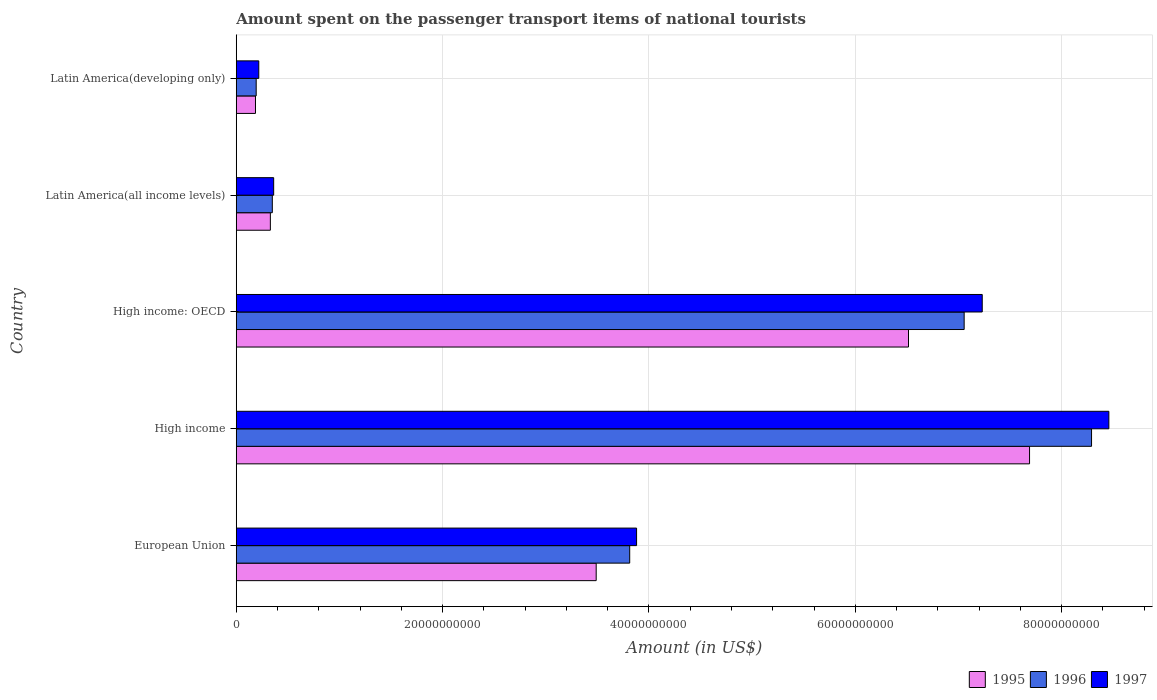How many different coloured bars are there?
Keep it short and to the point. 3. How many groups of bars are there?
Give a very brief answer. 5. Are the number of bars per tick equal to the number of legend labels?
Make the answer very short. Yes. Are the number of bars on each tick of the Y-axis equal?
Offer a terse response. Yes. How many bars are there on the 3rd tick from the bottom?
Ensure brevity in your answer.  3. What is the amount spent on the passenger transport items of national tourists in 1996 in Latin America(developing only)?
Ensure brevity in your answer.  1.93e+09. Across all countries, what is the maximum amount spent on the passenger transport items of national tourists in 1997?
Provide a short and direct response. 8.46e+1. Across all countries, what is the minimum amount spent on the passenger transport items of national tourists in 1995?
Make the answer very short. 1.86e+09. In which country was the amount spent on the passenger transport items of national tourists in 1995 minimum?
Give a very brief answer. Latin America(developing only). What is the total amount spent on the passenger transport items of national tourists in 1996 in the graph?
Offer a very short reply. 1.97e+11. What is the difference between the amount spent on the passenger transport items of national tourists in 1996 in Latin America(all income levels) and that in Latin America(developing only)?
Make the answer very short. 1.56e+09. What is the difference between the amount spent on the passenger transport items of national tourists in 1995 in European Union and the amount spent on the passenger transport items of national tourists in 1996 in High income?
Provide a short and direct response. -4.80e+1. What is the average amount spent on the passenger transport items of national tourists in 1996 per country?
Provide a succinct answer. 3.94e+1. What is the difference between the amount spent on the passenger transport items of national tourists in 1996 and amount spent on the passenger transport items of national tourists in 1995 in High income?
Ensure brevity in your answer.  6.01e+09. In how many countries, is the amount spent on the passenger transport items of national tourists in 1996 greater than 72000000000 US$?
Your answer should be compact. 1. What is the ratio of the amount spent on the passenger transport items of national tourists in 1996 in High income to that in Latin America(all income levels)?
Your response must be concise. 23.72. Is the difference between the amount spent on the passenger transport items of national tourists in 1996 in High income and Latin America(developing only) greater than the difference between the amount spent on the passenger transport items of national tourists in 1995 in High income and Latin America(developing only)?
Keep it short and to the point. Yes. What is the difference between the highest and the second highest amount spent on the passenger transport items of national tourists in 1996?
Give a very brief answer. 1.23e+1. What is the difference between the highest and the lowest amount spent on the passenger transport items of national tourists in 1997?
Keep it short and to the point. 8.24e+1. What does the 1st bar from the bottom in High income: OECD represents?
Keep it short and to the point. 1995. How many bars are there?
Offer a terse response. 15. How many countries are there in the graph?
Keep it short and to the point. 5. What is the difference between two consecutive major ticks on the X-axis?
Offer a terse response. 2.00e+1. Are the values on the major ticks of X-axis written in scientific E-notation?
Provide a succinct answer. No. Does the graph contain any zero values?
Provide a succinct answer. No. Does the graph contain grids?
Offer a very short reply. Yes. Where does the legend appear in the graph?
Make the answer very short. Bottom right. How are the legend labels stacked?
Your answer should be very brief. Horizontal. What is the title of the graph?
Offer a very short reply. Amount spent on the passenger transport items of national tourists. Does "1984" appear as one of the legend labels in the graph?
Provide a short and direct response. No. What is the label or title of the X-axis?
Your answer should be very brief. Amount (in US$). What is the Amount (in US$) of 1995 in European Union?
Make the answer very short. 3.49e+1. What is the Amount (in US$) in 1996 in European Union?
Provide a succinct answer. 3.81e+1. What is the Amount (in US$) in 1997 in European Union?
Provide a succinct answer. 3.88e+1. What is the Amount (in US$) of 1995 in High income?
Ensure brevity in your answer.  7.69e+1. What is the Amount (in US$) of 1996 in High income?
Make the answer very short. 8.29e+1. What is the Amount (in US$) in 1997 in High income?
Offer a terse response. 8.46e+1. What is the Amount (in US$) in 1995 in High income: OECD?
Your response must be concise. 6.52e+1. What is the Amount (in US$) in 1996 in High income: OECD?
Make the answer very short. 7.06e+1. What is the Amount (in US$) in 1997 in High income: OECD?
Keep it short and to the point. 7.23e+1. What is the Amount (in US$) of 1995 in Latin America(all income levels)?
Your response must be concise. 3.31e+09. What is the Amount (in US$) in 1996 in Latin America(all income levels)?
Offer a very short reply. 3.50e+09. What is the Amount (in US$) in 1997 in Latin America(all income levels)?
Provide a short and direct response. 3.63e+09. What is the Amount (in US$) in 1995 in Latin America(developing only)?
Ensure brevity in your answer.  1.86e+09. What is the Amount (in US$) of 1996 in Latin America(developing only)?
Provide a succinct answer. 1.93e+09. What is the Amount (in US$) in 1997 in Latin America(developing only)?
Keep it short and to the point. 2.18e+09. Across all countries, what is the maximum Amount (in US$) of 1995?
Make the answer very short. 7.69e+1. Across all countries, what is the maximum Amount (in US$) of 1996?
Offer a very short reply. 8.29e+1. Across all countries, what is the maximum Amount (in US$) of 1997?
Offer a terse response. 8.46e+1. Across all countries, what is the minimum Amount (in US$) of 1995?
Give a very brief answer. 1.86e+09. Across all countries, what is the minimum Amount (in US$) of 1996?
Offer a very short reply. 1.93e+09. Across all countries, what is the minimum Amount (in US$) in 1997?
Provide a succinct answer. 2.18e+09. What is the total Amount (in US$) in 1995 in the graph?
Give a very brief answer. 1.82e+11. What is the total Amount (in US$) in 1996 in the graph?
Provide a succinct answer. 1.97e+11. What is the total Amount (in US$) in 1997 in the graph?
Your answer should be compact. 2.01e+11. What is the difference between the Amount (in US$) of 1995 in European Union and that in High income?
Your answer should be very brief. -4.20e+1. What is the difference between the Amount (in US$) in 1996 in European Union and that in High income?
Provide a succinct answer. -4.48e+1. What is the difference between the Amount (in US$) of 1997 in European Union and that in High income?
Provide a short and direct response. -4.58e+1. What is the difference between the Amount (in US$) of 1995 in European Union and that in High income: OECD?
Give a very brief answer. -3.03e+1. What is the difference between the Amount (in US$) in 1996 in European Union and that in High income: OECD?
Provide a short and direct response. -3.24e+1. What is the difference between the Amount (in US$) of 1997 in European Union and that in High income: OECD?
Your answer should be compact. -3.35e+1. What is the difference between the Amount (in US$) in 1995 in European Union and that in Latin America(all income levels)?
Offer a terse response. 3.16e+1. What is the difference between the Amount (in US$) in 1996 in European Union and that in Latin America(all income levels)?
Offer a very short reply. 3.46e+1. What is the difference between the Amount (in US$) in 1997 in European Union and that in Latin America(all income levels)?
Keep it short and to the point. 3.52e+1. What is the difference between the Amount (in US$) of 1995 in European Union and that in Latin America(developing only)?
Provide a succinct answer. 3.30e+1. What is the difference between the Amount (in US$) in 1996 in European Union and that in Latin America(developing only)?
Provide a short and direct response. 3.62e+1. What is the difference between the Amount (in US$) of 1997 in European Union and that in Latin America(developing only)?
Your answer should be compact. 3.66e+1. What is the difference between the Amount (in US$) of 1995 in High income and that in High income: OECD?
Give a very brief answer. 1.17e+1. What is the difference between the Amount (in US$) in 1996 in High income and that in High income: OECD?
Keep it short and to the point. 1.23e+1. What is the difference between the Amount (in US$) of 1997 in High income and that in High income: OECD?
Make the answer very short. 1.23e+1. What is the difference between the Amount (in US$) of 1995 in High income and that in Latin America(all income levels)?
Your answer should be compact. 7.36e+1. What is the difference between the Amount (in US$) in 1996 in High income and that in Latin America(all income levels)?
Make the answer very short. 7.94e+1. What is the difference between the Amount (in US$) of 1997 in High income and that in Latin America(all income levels)?
Your answer should be very brief. 8.10e+1. What is the difference between the Amount (in US$) in 1995 in High income and that in Latin America(developing only)?
Give a very brief answer. 7.50e+1. What is the difference between the Amount (in US$) of 1996 in High income and that in Latin America(developing only)?
Offer a very short reply. 8.10e+1. What is the difference between the Amount (in US$) in 1997 in High income and that in Latin America(developing only)?
Provide a short and direct response. 8.24e+1. What is the difference between the Amount (in US$) in 1995 in High income: OECD and that in Latin America(all income levels)?
Your answer should be very brief. 6.19e+1. What is the difference between the Amount (in US$) in 1996 in High income: OECD and that in Latin America(all income levels)?
Your answer should be compact. 6.71e+1. What is the difference between the Amount (in US$) of 1997 in High income: OECD and that in Latin America(all income levels)?
Provide a succinct answer. 6.87e+1. What is the difference between the Amount (in US$) of 1995 in High income: OECD and that in Latin America(developing only)?
Keep it short and to the point. 6.33e+1. What is the difference between the Amount (in US$) in 1996 in High income: OECD and that in Latin America(developing only)?
Provide a short and direct response. 6.86e+1. What is the difference between the Amount (in US$) of 1997 in High income: OECD and that in Latin America(developing only)?
Offer a terse response. 7.01e+1. What is the difference between the Amount (in US$) in 1995 in Latin America(all income levels) and that in Latin America(developing only)?
Your response must be concise. 1.44e+09. What is the difference between the Amount (in US$) in 1996 in Latin America(all income levels) and that in Latin America(developing only)?
Offer a very short reply. 1.56e+09. What is the difference between the Amount (in US$) in 1997 in Latin America(all income levels) and that in Latin America(developing only)?
Provide a short and direct response. 1.44e+09. What is the difference between the Amount (in US$) of 1995 in European Union and the Amount (in US$) of 1996 in High income?
Ensure brevity in your answer.  -4.80e+1. What is the difference between the Amount (in US$) of 1995 in European Union and the Amount (in US$) of 1997 in High income?
Your response must be concise. -4.97e+1. What is the difference between the Amount (in US$) in 1996 in European Union and the Amount (in US$) in 1997 in High income?
Keep it short and to the point. -4.64e+1. What is the difference between the Amount (in US$) in 1995 in European Union and the Amount (in US$) in 1996 in High income: OECD?
Your answer should be compact. -3.57e+1. What is the difference between the Amount (in US$) of 1995 in European Union and the Amount (in US$) of 1997 in High income: OECD?
Give a very brief answer. -3.74e+1. What is the difference between the Amount (in US$) of 1996 in European Union and the Amount (in US$) of 1997 in High income: OECD?
Give a very brief answer. -3.42e+1. What is the difference between the Amount (in US$) of 1995 in European Union and the Amount (in US$) of 1996 in Latin America(all income levels)?
Give a very brief answer. 3.14e+1. What is the difference between the Amount (in US$) in 1995 in European Union and the Amount (in US$) in 1997 in Latin America(all income levels)?
Your answer should be compact. 3.13e+1. What is the difference between the Amount (in US$) of 1996 in European Union and the Amount (in US$) of 1997 in Latin America(all income levels)?
Keep it short and to the point. 3.45e+1. What is the difference between the Amount (in US$) of 1995 in European Union and the Amount (in US$) of 1996 in Latin America(developing only)?
Keep it short and to the point. 3.30e+1. What is the difference between the Amount (in US$) in 1995 in European Union and the Amount (in US$) in 1997 in Latin America(developing only)?
Keep it short and to the point. 3.27e+1. What is the difference between the Amount (in US$) of 1996 in European Union and the Amount (in US$) of 1997 in Latin America(developing only)?
Your answer should be very brief. 3.60e+1. What is the difference between the Amount (in US$) of 1995 in High income and the Amount (in US$) of 1996 in High income: OECD?
Offer a very short reply. 6.34e+09. What is the difference between the Amount (in US$) in 1995 in High income and the Amount (in US$) in 1997 in High income: OECD?
Keep it short and to the point. 4.59e+09. What is the difference between the Amount (in US$) in 1996 in High income and the Amount (in US$) in 1997 in High income: OECD?
Offer a terse response. 1.06e+1. What is the difference between the Amount (in US$) in 1995 in High income and the Amount (in US$) in 1996 in Latin America(all income levels)?
Ensure brevity in your answer.  7.34e+1. What is the difference between the Amount (in US$) in 1995 in High income and the Amount (in US$) in 1997 in Latin America(all income levels)?
Provide a short and direct response. 7.33e+1. What is the difference between the Amount (in US$) of 1996 in High income and the Amount (in US$) of 1997 in Latin America(all income levels)?
Your answer should be compact. 7.93e+1. What is the difference between the Amount (in US$) in 1995 in High income and the Amount (in US$) in 1996 in Latin America(developing only)?
Make the answer very short. 7.50e+1. What is the difference between the Amount (in US$) of 1995 in High income and the Amount (in US$) of 1997 in Latin America(developing only)?
Your answer should be compact. 7.47e+1. What is the difference between the Amount (in US$) of 1996 in High income and the Amount (in US$) of 1997 in Latin America(developing only)?
Keep it short and to the point. 8.07e+1. What is the difference between the Amount (in US$) in 1995 in High income: OECD and the Amount (in US$) in 1996 in Latin America(all income levels)?
Your answer should be very brief. 6.17e+1. What is the difference between the Amount (in US$) of 1995 in High income: OECD and the Amount (in US$) of 1997 in Latin America(all income levels)?
Provide a short and direct response. 6.15e+1. What is the difference between the Amount (in US$) of 1996 in High income: OECD and the Amount (in US$) of 1997 in Latin America(all income levels)?
Give a very brief answer. 6.69e+1. What is the difference between the Amount (in US$) in 1995 in High income: OECD and the Amount (in US$) in 1996 in Latin America(developing only)?
Your response must be concise. 6.32e+1. What is the difference between the Amount (in US$) in 1995 in High income: OECD and the Amount (in US$) in 1997 in Latin America(developing only)?
Your answer should be very brief. 6.30e+1. What is the difference between the Amount (in US$) of 1996 in High income: OECD and the Amount (in US$) of 1997 in Latin America(developing only)?
Offer a terse response. 6.84e+1. What is the difference between the Amount (in US$) in 1995 in Latin America(all income levels) and the Amount (in US$) in 1996 in Latin America(developing only)?
Ensure brevity in your answer.  1.37e+09. What is the difference between the Amount (in US$) of 1995 in Latin America(all income levels) and the Amount (in US$) of 1997 in Latin America(developing only)?
Make the answer very short. 1.12e+09. What is the difference between the Amount (in US$) in 1996 in Latin America(all income levels) and the Amount (in US$) in 1997 in Latin America(developing only)?
Your answer should be very brief. 1.31e+09. What is the average Amount (in US$) in 1995 per country?
Offer a terse response. 3.64e+1. What is the average Amount (in US$) of 1996 per country?
Ensure brevity in your answer.  3.94e+1. What is the average Amount (in US$) in 1997 per country?
Ensure brevity in your answer.  4.03e+1. What is the difference between the Amount (in US$) of 1995 and Amount (in US$) of 1996 in European Union?
Your answer should be very brief. -3.25e+09. What is the difference between the Amount (in US$) in 1995 and Amount (in US$) in 1997 in European Union?
Offer a very short reply. -3.92e+09. What is the difference between the Amount (in US$) in 1996 and Amount (in US$) in 1997 in European Union?
Provide a short and direct response. -6.67e+08. What is the difference between the Amount (in US$) in 1995 and Amount (in US$) in 1996 in High income?
Your response must be concise. -6.01e+09. What is the difference between the Amount (in US$) of 1995 and Amount (in US$) of 1997 in High income?
Your answer should be very brief. -7.69e+09. What is the difference between the Amount (in US$) of 1996 and Amount (in US$) of 1997 in High income?
Ensure brevity in your answer.  -1.68e+09. What is the difference between the Amount (in US$) of 1995 and Amount (in US$) of 1996 in High income: OECD?
Keep it short and to the point. -5.40e+09. What is the difference between the Amount (in US$) in 1995 and Amount (in US$) in 1997 in High income: OECD?
Your answer should be very brief. -7.15e+09. What is the difference between the Amount (in US$) of 1996 and Amount (in US$) of 1997 in High income: OECD?
Your answer should be compact. -1.75e+09. What is the difference between the Amount (in US$) of 1995 and Amount (in US$) of 1996 in Latin America(all income levels)?
Offer a terse response. -1.89e+08. What is the difference between the Amount (in US$) in 1995 and Amount (in US$) in 1997 in Latin America(all income levels)?
Ensure brevity in your answer.  -3.20e+08. What is the difference between the Amount (in US$) of 1996 and Amount (in US$) of 1997 in Latin America(all income levels)?
Keep it short and to the point. -1.31e+08. What is the difference between the Amount (in US$) in 1995 and Amount (in US$) in 1996 in Latin America(developing only)?
Your response must be concise. -6.84e+07. What is the difference between the Amount (in US$) of 1995 and Amount (in US$) of 1997 in Latin America(developing only)?
Provide a succinct answer. -3.19e+08. What is the difference between the Amount (in US$) in 1996 and Amount (in US$) in 1997 in Latin America(developing only)?
Offer a very short reply. -2.50e+08. What is the ratio of the Amount (in US$) of 1995 in European Union to that in High income?
Your answer should be very brief. 0.45. What is the ratio of the Amount (in US$) in 1996 in European Union to that in High income?
Offer a terse response. 0.46. What is the ratio of the Amount (in US$) in 1997 in European Union to that in High income?
Offer a terse response. 0.46. What is the ratio of the Amount (in US$) of 1995 in European Union to that in High income: OECD?
Offer a very short reply. 0.54. What is the ratio of the Amount (in US$) in 1996 in European Union to that in High income: OECD?
Your response must be concise. 0.54. What is the ratio of the Amount (in US$) of 1997 in European Union to that in High income: OECD?
Offer a very short reply. 0.54. What is the ratio of the Amount (in US$) in 1995 in European Union to that in Latin America(all income levels)?
Offer a terse response. 10.55. What is the ratio of the Amount (in US$) of 1996 in European Union to that in Latin America(all income levels)?
Your answer should be very brief. 10.91. What is the ratio of the Amount (in US$) in 1997 in European Union to that in Latin America(all income levels)?
Offer a very short reply. 10.7. What is the ratio of the Amount (in US$) of 1995 in European Union to that in Latin America(developing only)?
Give a very brief answer. 18.71. What is the ratio of the Amount (in US$) in 1996 in European Union to that in Latin America(developing only)?
Give a very brief answer. 19.73. What is the ratio of the Amount (in US$) in 1997 in European Union to that in Latin America(developing only)?
Ensure brevity in your answer.  17.78. What is the ratio of the Amount (in US$) of 1995 in High income to that in High income: OECD?
Ensure brevity in your answer.  1.18. What is the ratio of the Amount (in US$) of 1996 in High income to that in High income: OECD?
Offer a very short reply. 1.18. What is the ratio of the Amount (in US$) of 1997 in High income to that in High income: OECD?
Your answer should be compact. 1.17. What is the ratio of the Amount (in US$) of 1995 in High income to that in Latin America(all income levels)?
Provide a short and direct response. 23.26. What is the ratio of the Amount (in US$) in 1996 in High income to that in Latin America(all income levels)?
Your answer should be compact. 23.72. What is the ratio of the Amount (in US$) of 1997 in High income to that in Latin America(all income levels)?
Your answer should be very brief. 23.32. What is the ratio of the Amount (in US$) of 1995 in High income to that in Latin America(developing only)?
Keep it short and to the point. 41.24. What is the ratio of the Amount (in US$) in 1996 in High income to that in Latin America(developing only)?
Provide a short and direct response. 42.9. What is the ratio of the Amount (in US$) of 1997 in High income to that in Latin America(developing only)?
Your answer should be very brief. 38.75. What is the ratio of the Amount (in US$) of 1995 in High income: OECD to that in Latin America(all income levels)?
Give a very brief answer. 19.71. What is the ratio of the Amount (in US$) in 1996 in High income: OECD to that in Latin America(all income levels)?
Your response must be concise. 20.19. What is the ratio of the Amount (in US$) in 1997 in High income: OECD to that in Latin America(all income levels)?
Keep it short and to the point. 19.94. What is the ratio of the Amount (in US$) of 1995 in High income: OECD to that in Latin America(developing only)?
Give a very brief answer. 34.95. What is the ratio of the Amount (in US$) of 1996 in High income: OECD to that in Latin America(developing only)?
Offer a very short reply. 36.51. What is the ratio of the Amount (in US$) of 1997 in High income: OECD to that in Latin America(developing only)?
Your answer should be compact. 33.12. What is the ratio of the Amount (in US$) in 1995 in Latin America(all income levels) to that in Latin America(developing only)?
Provide a succinct answer. 1.77. What is the ratio of the Amount (in US$) in 1996 in Latin America(all income levels) to that in Latin America(developing only)?
Keep it short and to the point. 1.81. What is the ratio of the Amount (in US$) in 1997 in Latin America(all income levels) to that in Latin America(developing only)?
Keep it short and to the point. 1.66. What is the difference between the highest and the second highest Amount (in US$) of 1995?
Your response must be concise. 1.17e+1. What is the difference between the highest and the second highest Amount (in US$) of 1996?
Your response must be concise. 1.23e+1. What is the difference between the highest and the second highest Amount (in US$) of 1997?
Ensure brevity in your answer.  1.23e+1. What is the difference between the highest and the lowest Amount (in US$) of 1995?
Offer a very short reply. 7.50e+1. What is the difference between the highest and the lowest Amount (in US$) of 1996?
Your answer should be compact. 8.10e+1. What is the difference between the highest and the lowest Amount (in US$) in 1997?
Ensure brevity in your answer.  8.24e+1. 